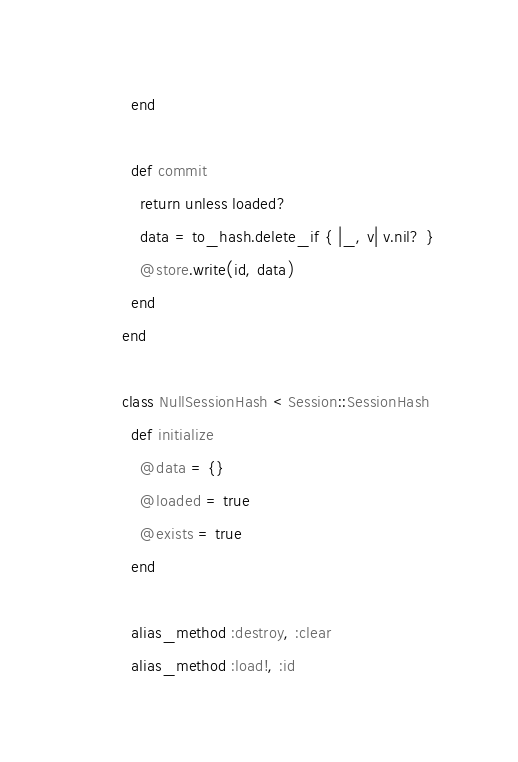<code> <loc_0><loc_0><loc_500><loc_500><_Ruby_>          end

          def commit
            return unless loaded?
            data = to_hash.delete_if { |_, v| v.nil? }
            @store.write(id, data)
          end
        end

        class NullSessionHash < Session::SessionHash
          def initialize
            @data = {}
            @loaded = true
            @exists = true
          end

          alias_method :destroy, :clear
          alias_method :load!, :id</code> 